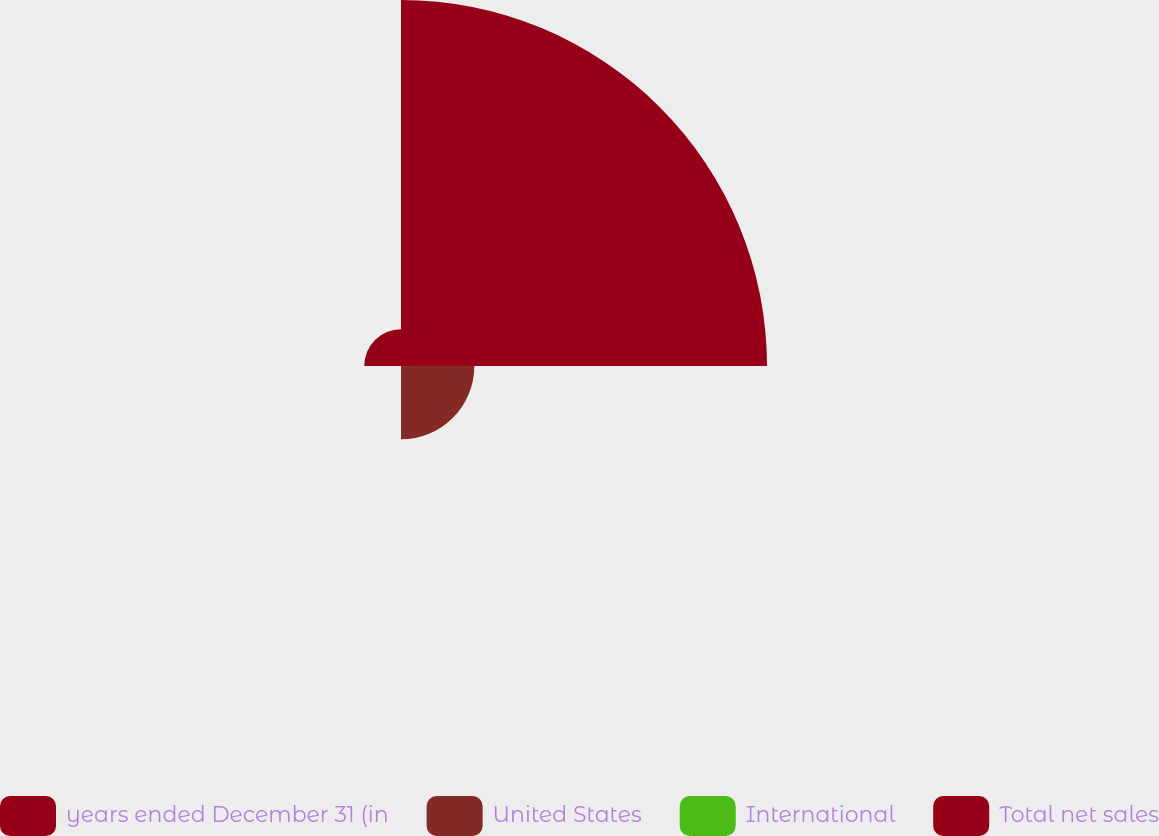Convert chart to OTSL. <chart><loc_0><loc_0><loc_500><loc_500><pie_chart><fcel>years ended December 31 (in<fcel>United States<fcel>International<fcel>Total net sales<nl><fcel>76.84%<fcel>15.4%<fcel>0.04%<fcel>7.72%<nl></chart> 